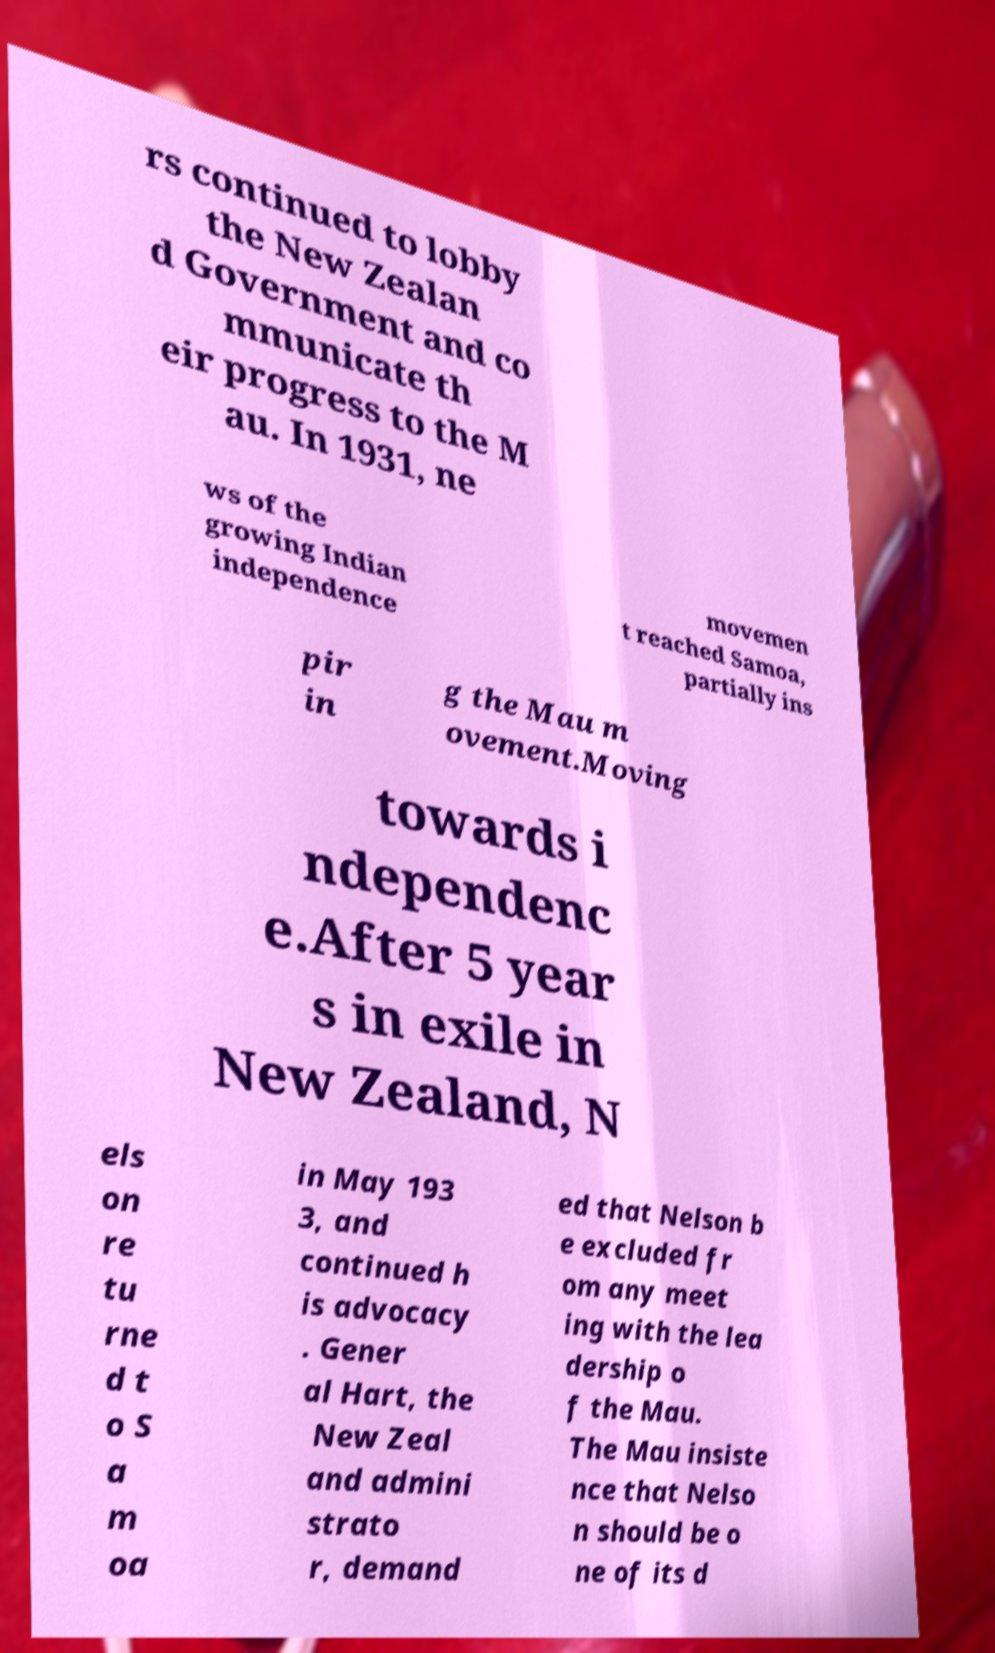I need the written content from this picture converted into text. Can you do that? rs continued to lobby the New Zealan d Government and co mmunicate th eir progress to the M au. In 1931, ne ws of the growing Indian independence movemen t reached Samoa, partially ins pir in g the Mau m ovement.Moving towards i ndependenc e.After 5 year s in exile in New Zealand, N els on re tu rne d t o S a m oa in May 193 3, and continued h is advocacy . Gener al Hart, the New Zeal and admini strato r, demand ed that Nelson b e excluded fr om any meet ing with the lea dership o f the Mau. The Mau insiste nce that Nelso n should be o ne of its d 